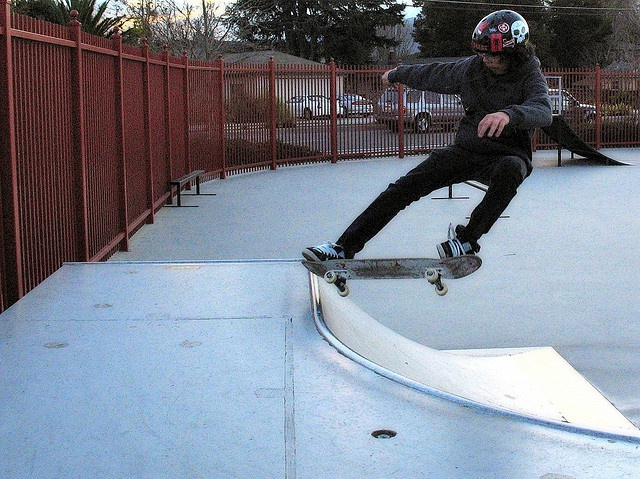Describe the objects in this image and their specific colors. I can see people in black, gray, and darkgray tones, skateboard in black, gray, and darkgray tones, car in black, gray, maroon, and darkgray tones, car in black, gray, and darkgray tones, and car in black, gray, white, and darkgray tones in this image. 